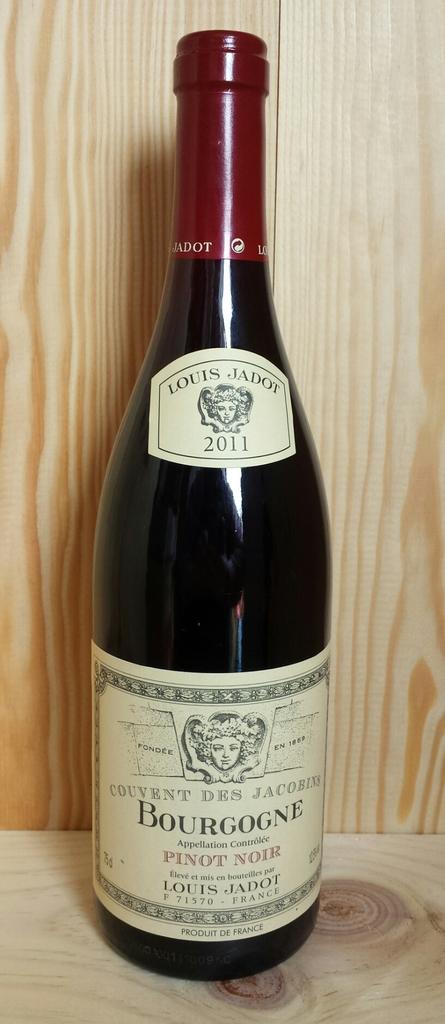What style of wine is the bottled filled with?
Provide a short and direct response. Pinot noir. What year is on the wine label?
Ensure brevity in your answer.  2011. 